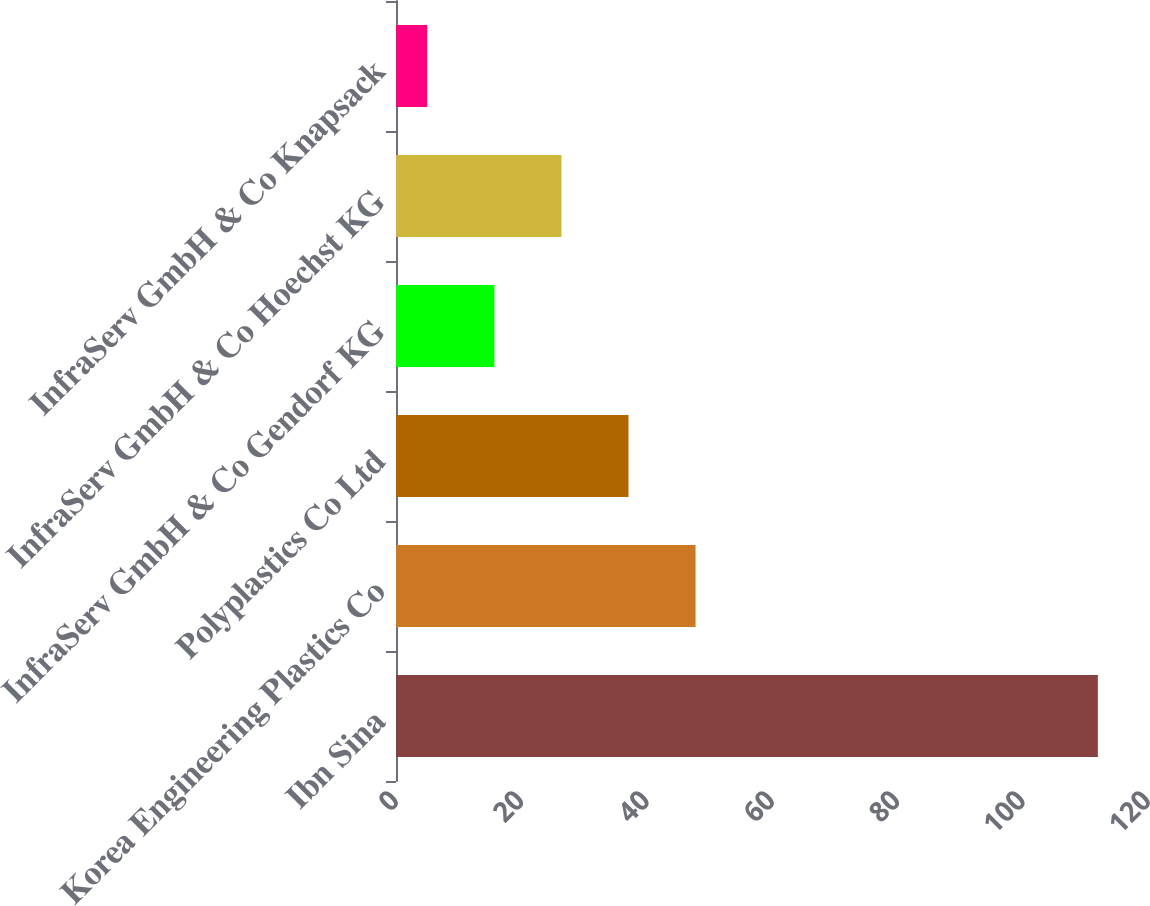<chart> <loc_0><loc_0><loc_500><loc_500><bar_chart><fcel>Ibn Sina<fcel>Korea Engineering Plastics Co<fcel>Polyplastics Co Ltd<fcel>InfraServ GmbH & Co Gendorf KG<fcel>InfraServ GmbH & Co Hoechst KG<fcel>InfraServ GmbH & Co Knapsack<nl><fcel>112<fcel>47.8<fcel>37.1<fcel>15.7<fcel>26.4<fcel>5<nl></chart> 